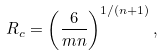<formula> <loc_0><loc_0><loc_500><loc_500>R _ { c } = \left ( \frac { 6 } { m n } \right ) ^ { 1 / ( n + 1 ) } , \</formula> 